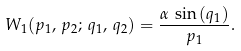<formula> <loc_0><loc_0><loc_500><loc_500>W _ { 1 } ( p _ { 1 } , \, p _ { 2 } ; \, q _ { 1 } , \, q _ { 2 } ) = \frac { \alpha \, \sin { ( { q _ { 1 } } ) } } { p _ { 1 } } .</formula> 